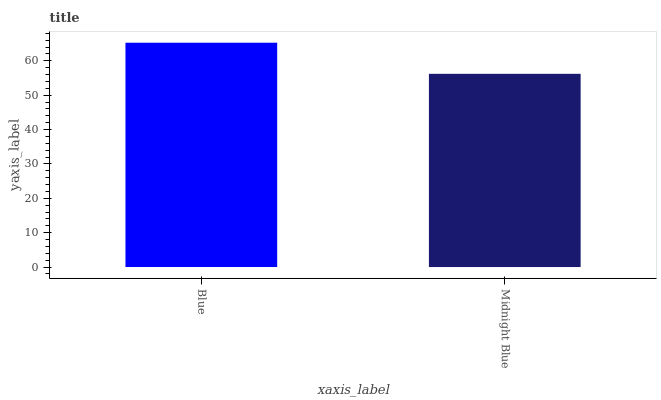Is Midnight Blue the maximum?
Answer yes or no. No. Is Blue greater than Midnight Blue?
Answer yes or no. Yes. Is Midnight Blue less than Blue?
Answer yes or no. Yes. Is Midnight Blue greater than Blue?
Answer yes or no. No. Is Blue less than Midnight Blue?
Answer yes or no. No. Is Blue the high median?
Answer yes or no. Yes. Is Midnight Blue the low median?
Answer yes or no. Yes. Is Midnight Blue the high median?
Answer yes or no. No. Is Blue the low median?
Answer yes or no. No. 